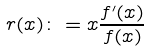<formula> <loc_0><loc_0><loc_500><loc_500>r ( x ) \colon = x \frac { f ^ { \prime } ( x ) } { f ( x ) }</formula> 